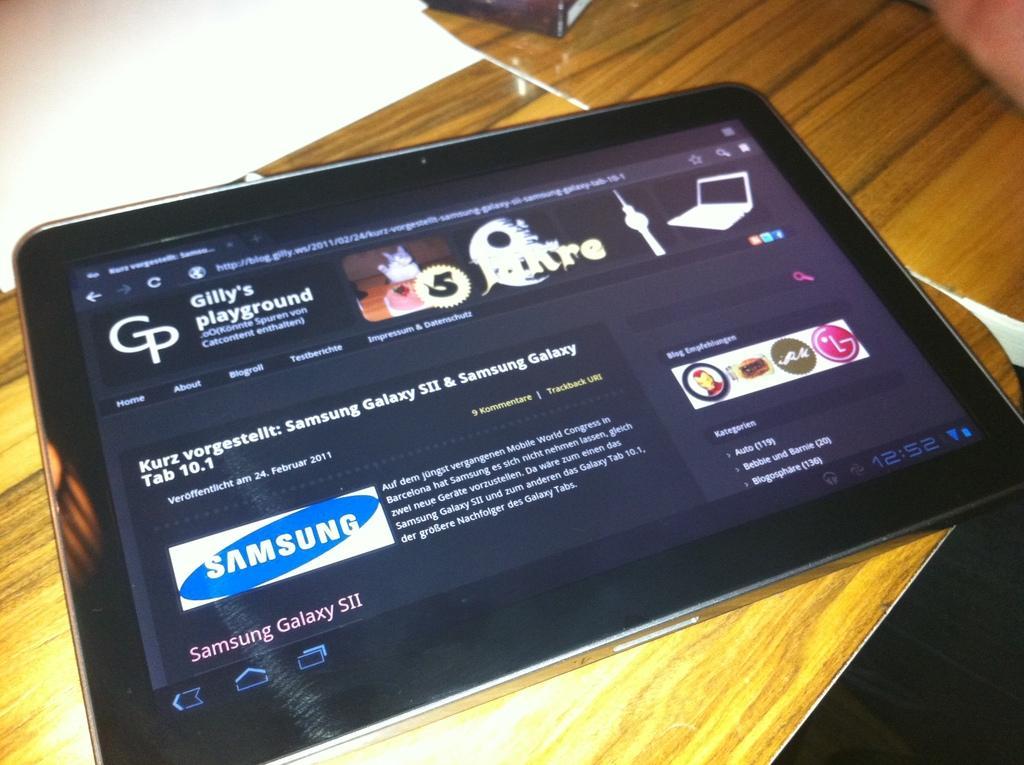Describe this image in one or two sentences. There is a tab on a wooden table on which, there are white papers. And the background is dark in color. 